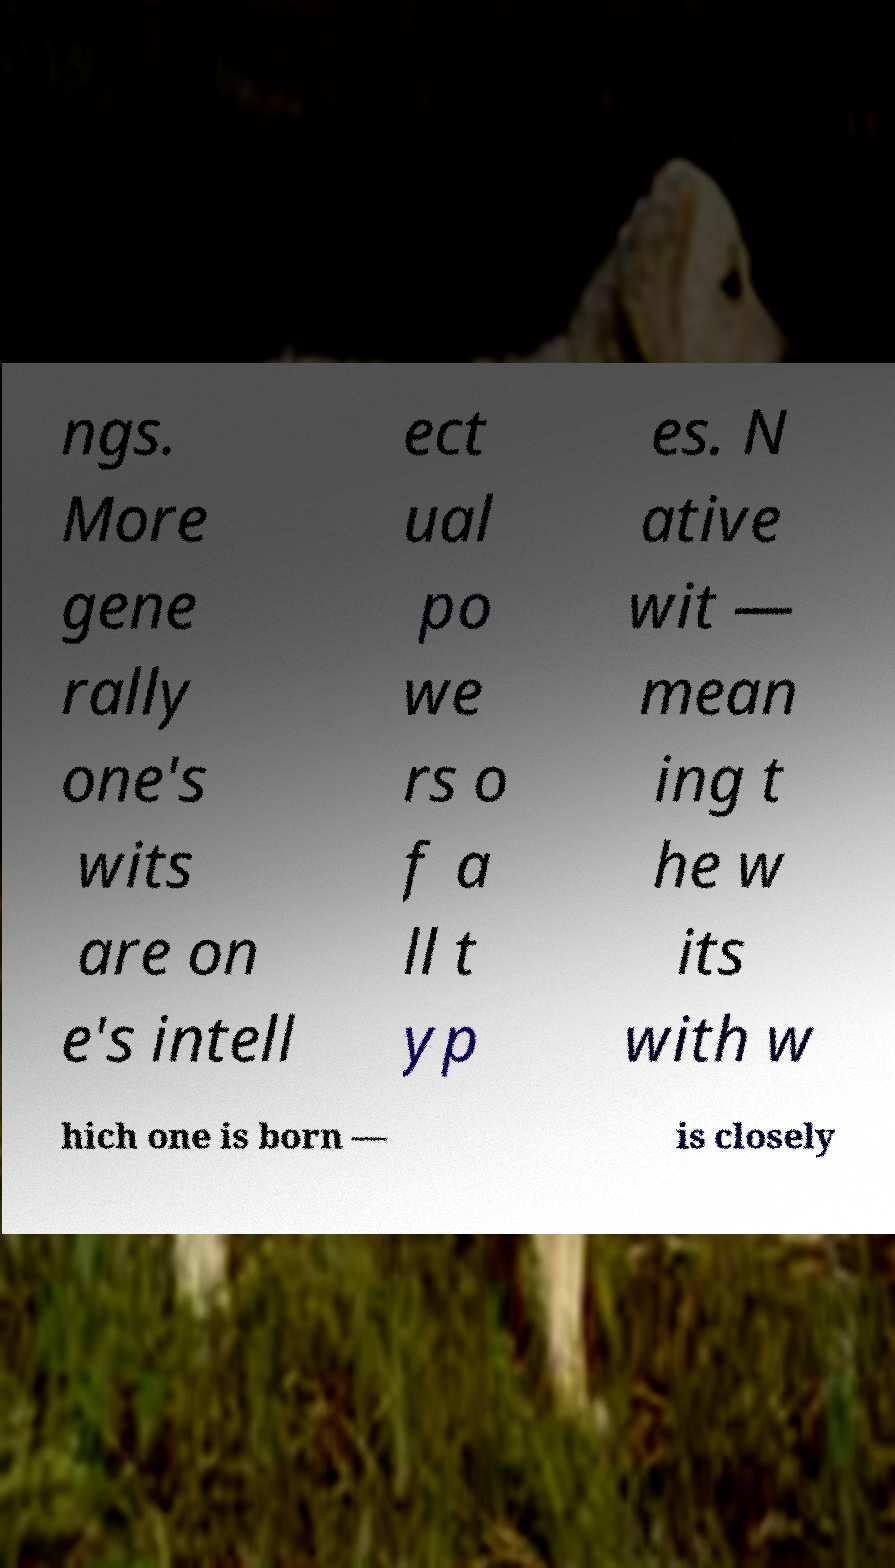There's text embedded in this image that I need extracted. Can you transcribe it verbatim? ngs. More gene rally one's wits are on e's intell ect ual po we rs o f a ll t yp es. N ative wit — mean ing t he w its with w hich one is born — is closely 